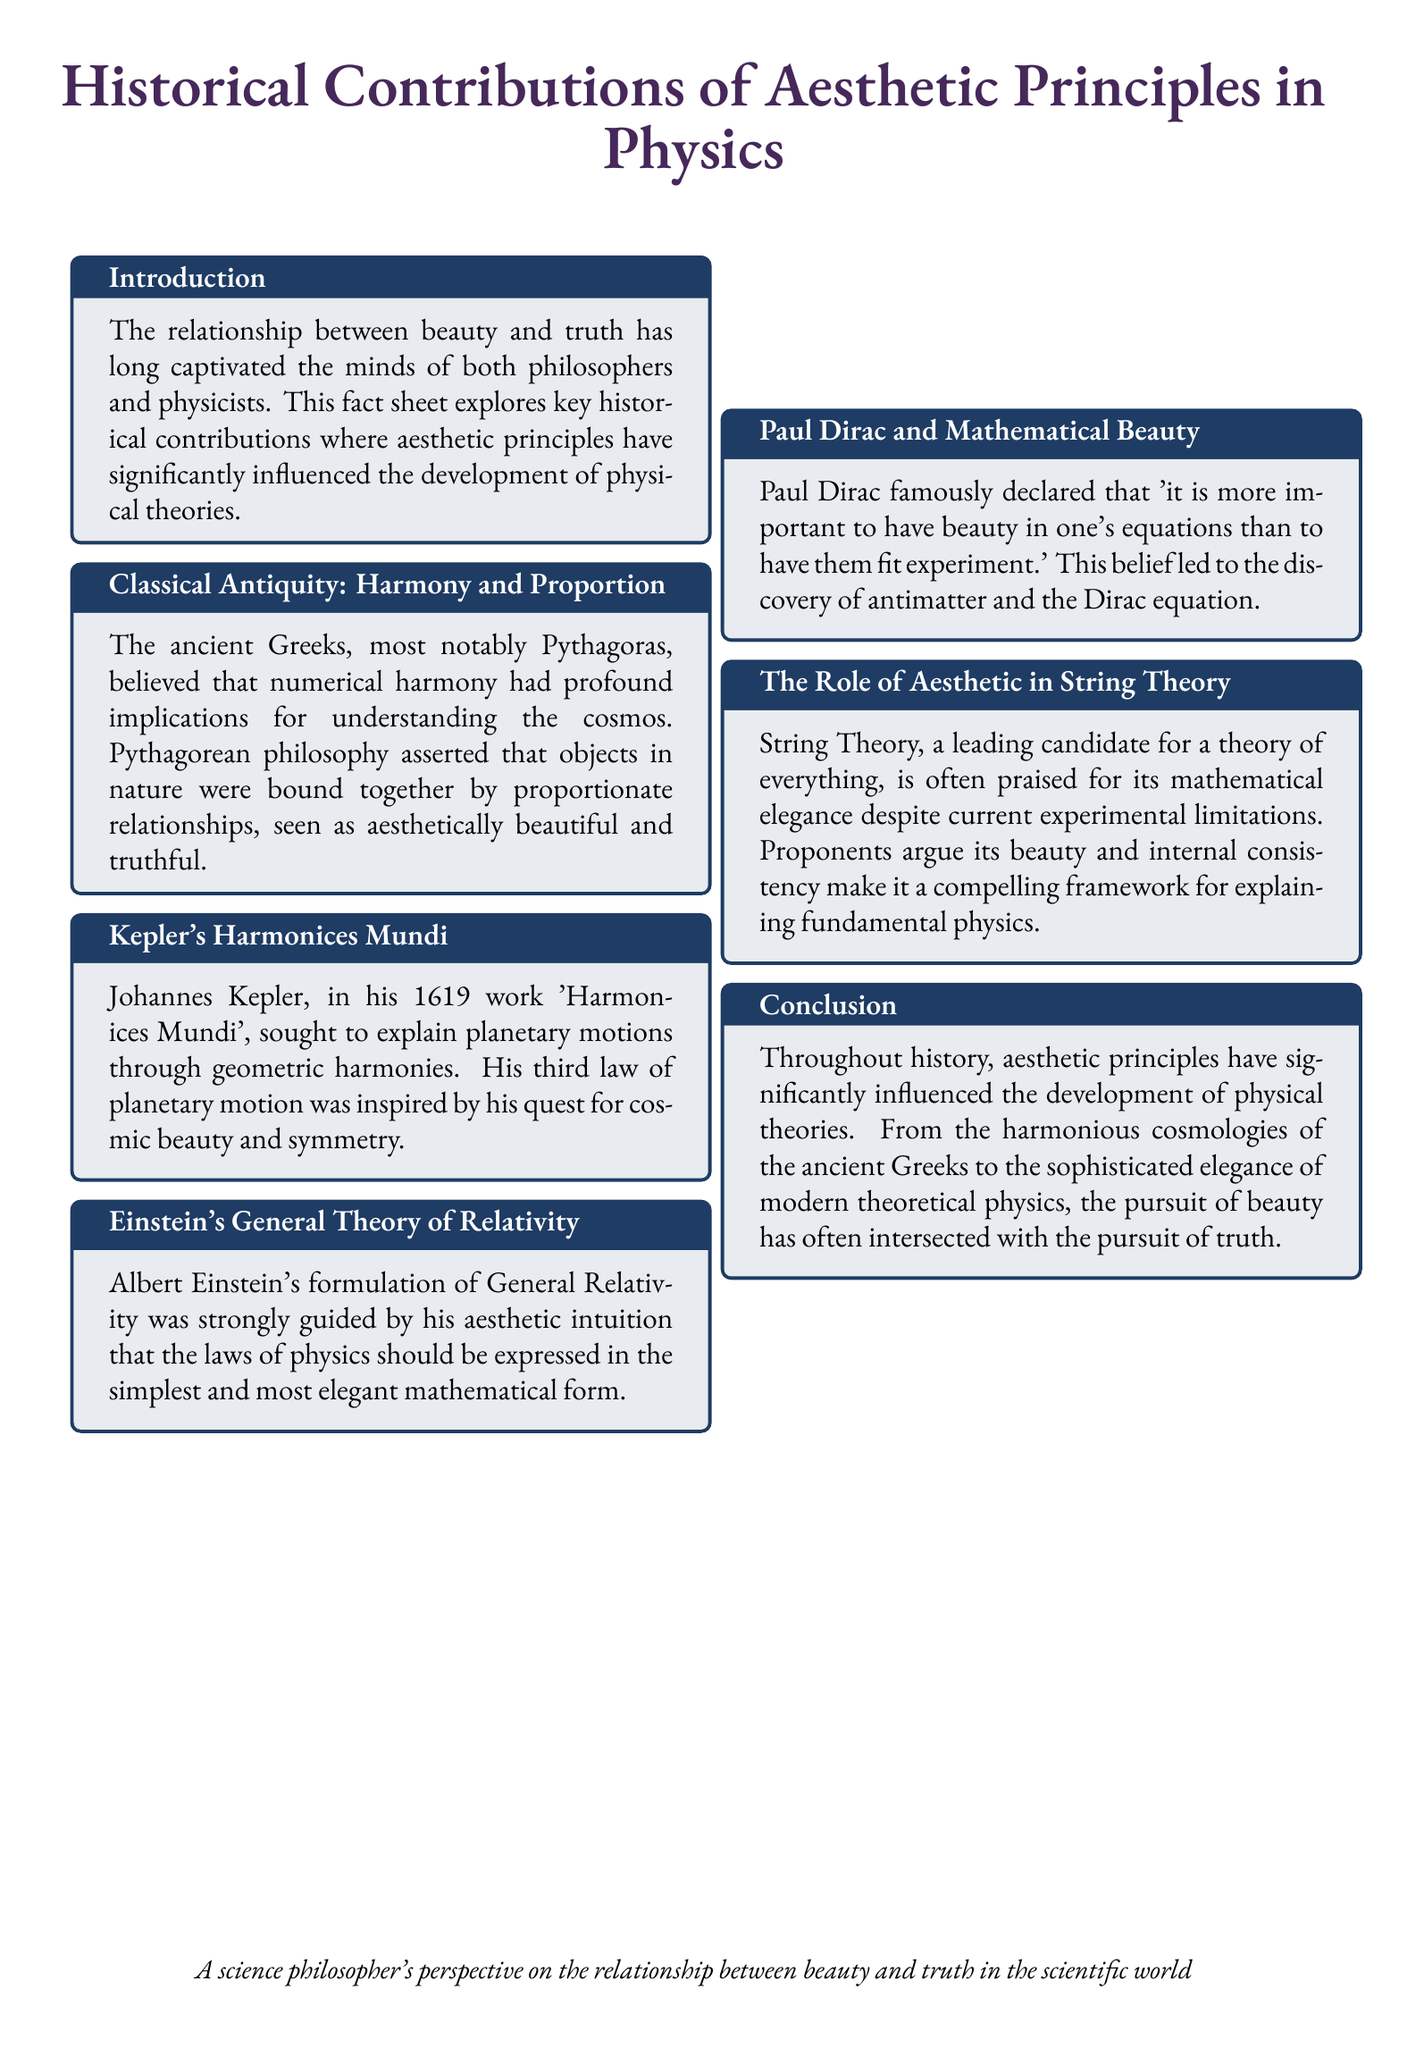What is the main theme of the document? The document explores the relationship between aesthetic principles and their influence on the development of physical theories.
Answer: relationship between beauty and truth Who proposed the idea of numerical harmony? The ancient Greeks, particularly Pythagoras, believed in numerical harmony's implications for understanding the cosmos.
Answer: Pythagoras In what year was Kepler's 'Harmonices Mundi' published? 'Harmonices Mundi' by Johannes Kepler was published in the year 1619.
Answer: 1619 What concept did Paul Dirac prioritize over experimental fit? Paul Dirac prioritized beauty in equations over fitting them to experiments.
Answer: beauty Which theory is praised for its mathematical elegance? String Theory is often praised for its mathematical elegance despite experimental limitations.
Answer: String Theory What does the document suggest beauty and truth have done throughout history? The document suggests that the pursuit of beauty has often intersected with the pursuit of truth throughout history.
Answer: intersected What type of document is this? This is a fact sheet outlining historical contributions of aesthetic principles in physics.
Answer: fact sheet Which physicist emphasized the importance of simplicity and elegance in mathematics? Albert Einstein emphasized that the laws of physics should be expressed in the simplest and most elegant form.
Answer: Albert Einstein What did Kepler's third law of planetary motion draw inspiration from? Kepler's third law of planetary motion was inspired by his quest for cosmic beauty and symmetry.
Answer: cosmic beauty and symmetry 